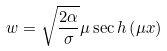<formula> <loc_0><loc_0><loc_500><loc_500>w = \sqrt { \frac { 2 \alpha } { \sigma } } \mu \sec h \left ( \mu x \right )</formula> 